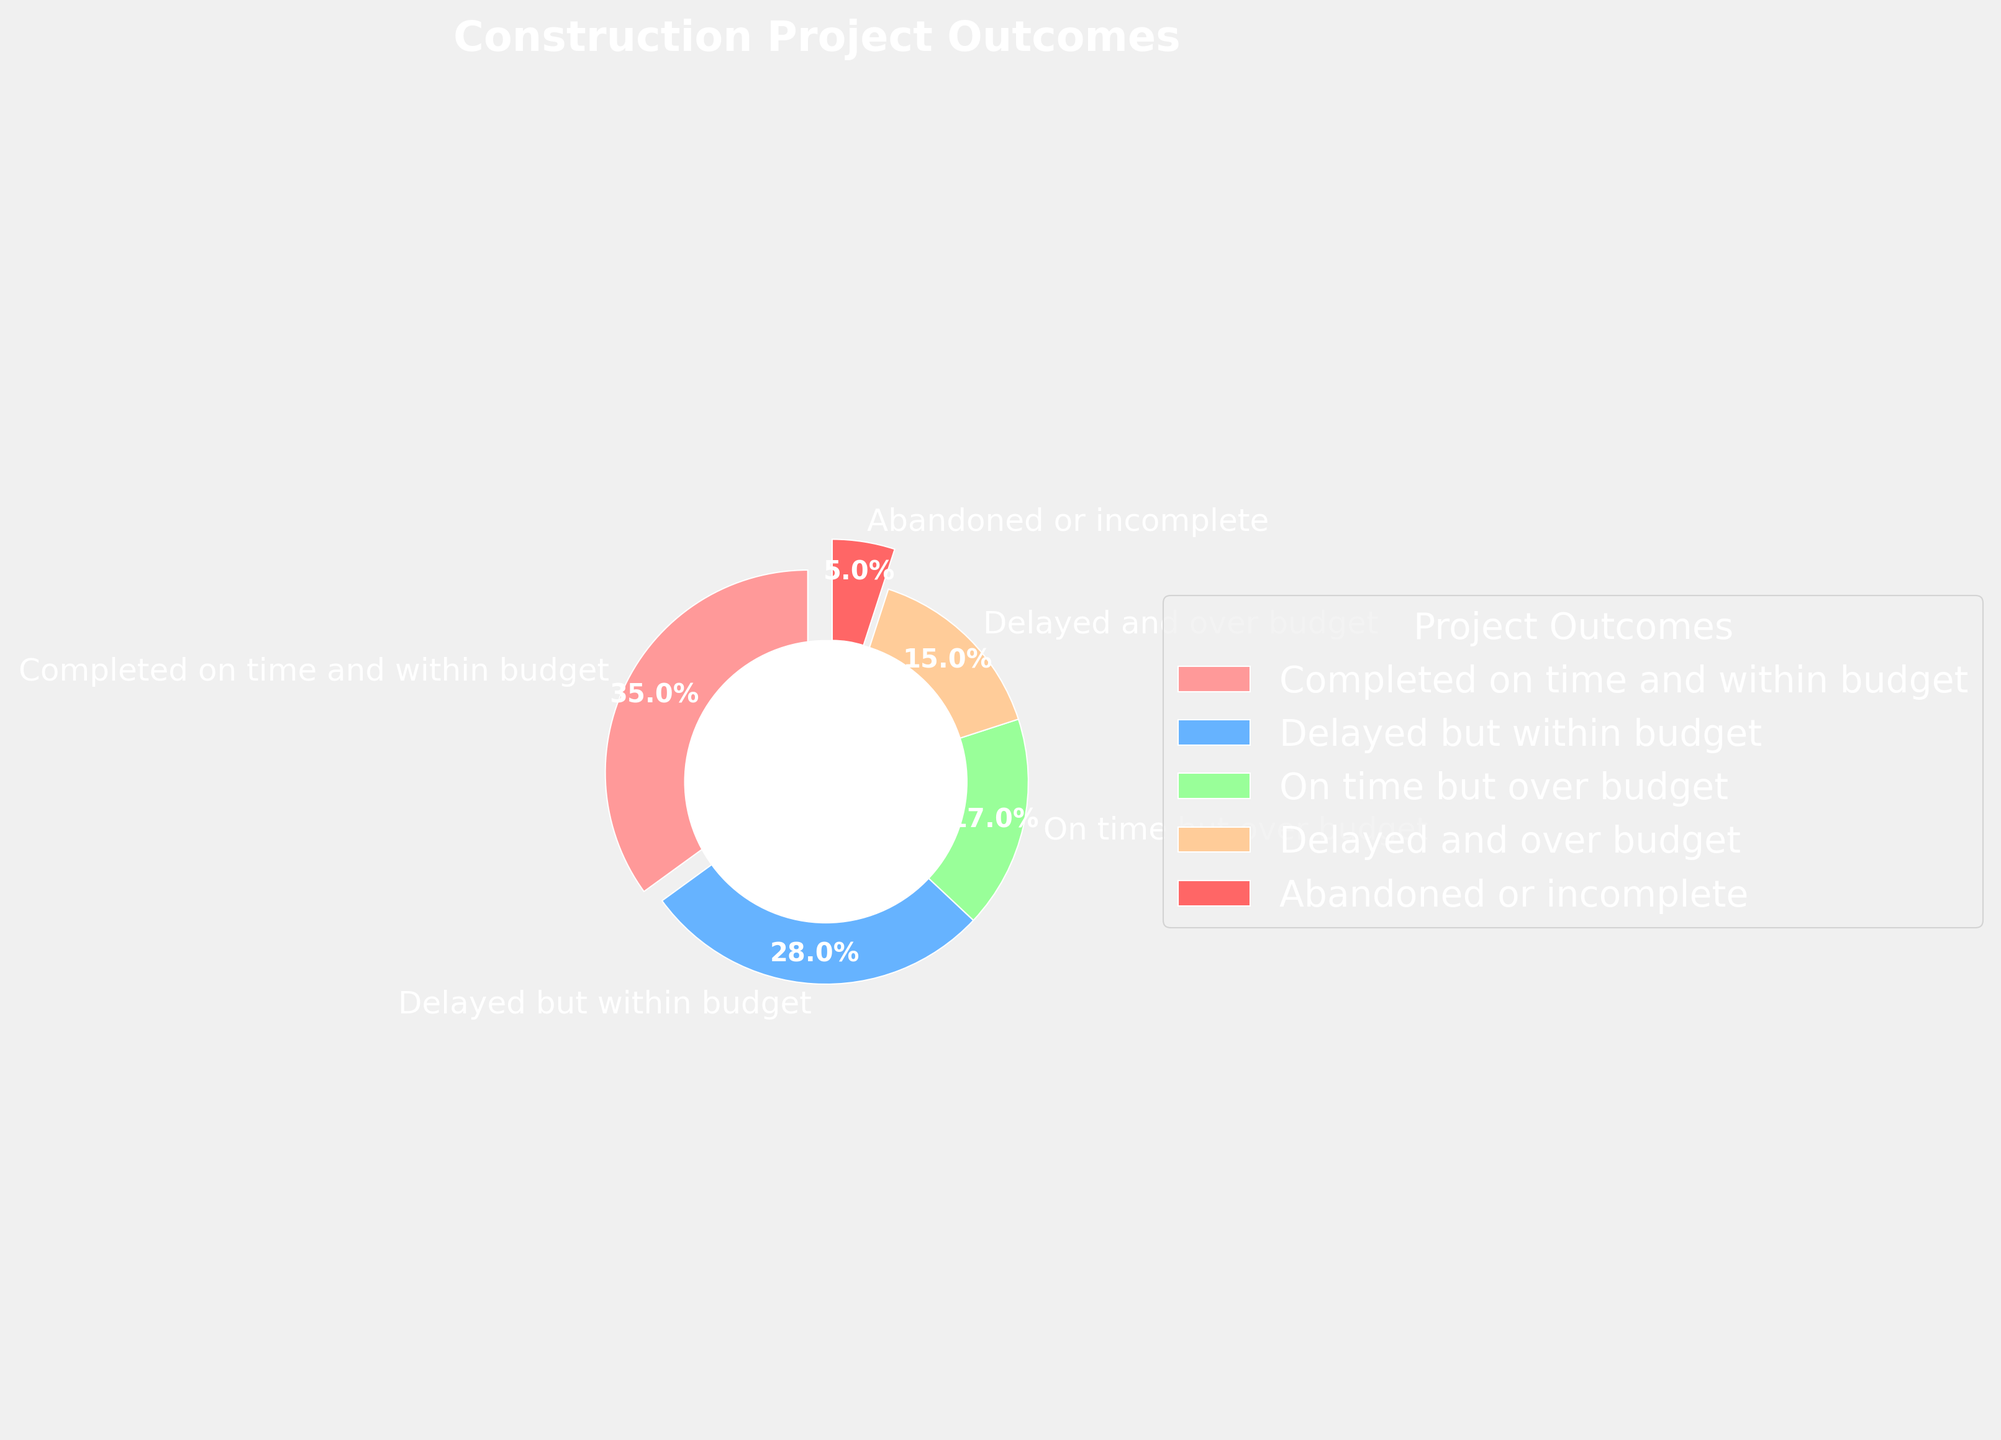What percentage of construction projects were completed on time? To answer this, identify the slice labeled "Completed on time and within budget" on the pie chart, as it represents projects completed on time.
Answer: 35% Which outcome represents the smallest percentage of construction projects? Look for the smallest slice in the pie chart. The label for the smallest slice will tell you the outcome it represents.
Answer: Abandoned or incomplete Are more projects completed on time and within budget, or delayed but within budget? Compare the size of the slices for "Completed on time and within budget" and "Delayed but within budget". The larger slice indicates the more frequent outcome.
Answer: Completed on time and within budget What is the combined percentage of projects that were either delayed or over budget (but not both)? Add the percentages of "Delayed but within budget" and "On time but over budget". The combined percentage is the sum of these percentages.
Answer: 28% + 17% = 45% How many times larger is the percentage of projects completed on time (and within budget) compared to projects that were abandoned or incomplete? Divide the percentage of "Completed on time and within budget" by the percentage of "Abandoned or incomplete". This ratio gives how many times larger one category is compared to the other.
Answer: 35% / 5% = 7 Is the percentage of projects delayed and over budget greater or less than those on time but over budget? Compare the slices labeled "Delayed and over budget" and "On time but over budget". The larger percentage indicates whether "Delayed and over budget" is greater or less.
Answer: Less (15% < 17%) Which color represents projects delayed but within budget? Identify the slice labeled "Delayed but within budget" and describe its color. This associates the outcome with its specific color.
Answer: Blue What is the combined percentage of projects that were delayed, regardless of the budget outcome? Add the percentages of "Delayed but within budget" and "Delayed and over budget". The combined percentage represents the total for delayed projects.
Answer: 28% + 15% = 43% How much more common are projects completed on time and within budget than delayed and over budget? Subtract the percentage of "Delayed and over budget" from the percentage of "Completed on time and within budget". The difference tells how much more common one outcome is compared to the other.
Answer: 35% - 15% = 20% Is the legend positioned to the right or left of the pie chart? Observe the position of the legend on the pie chart. Determining whether it is on the right or left helps in understanding the chart layout.
Answer: Right 